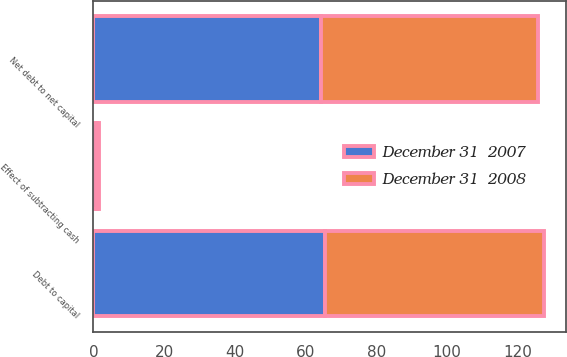Convert chart to OTSL. <chart><loc_0><loc_0><loc_500><loc_500><stacked_bar_chart><ecel><fcel>Net debt to net capital<fcel>Effect of subtracting cash<fcel>Debt to capital<nl><fcel>December 31  2008<fcel>61.5<fcel>0.5<fcel>62<nl><fcel>December 31  2007<fcel>64.4<fcel>1<fcel>65.4<nl></chart> 